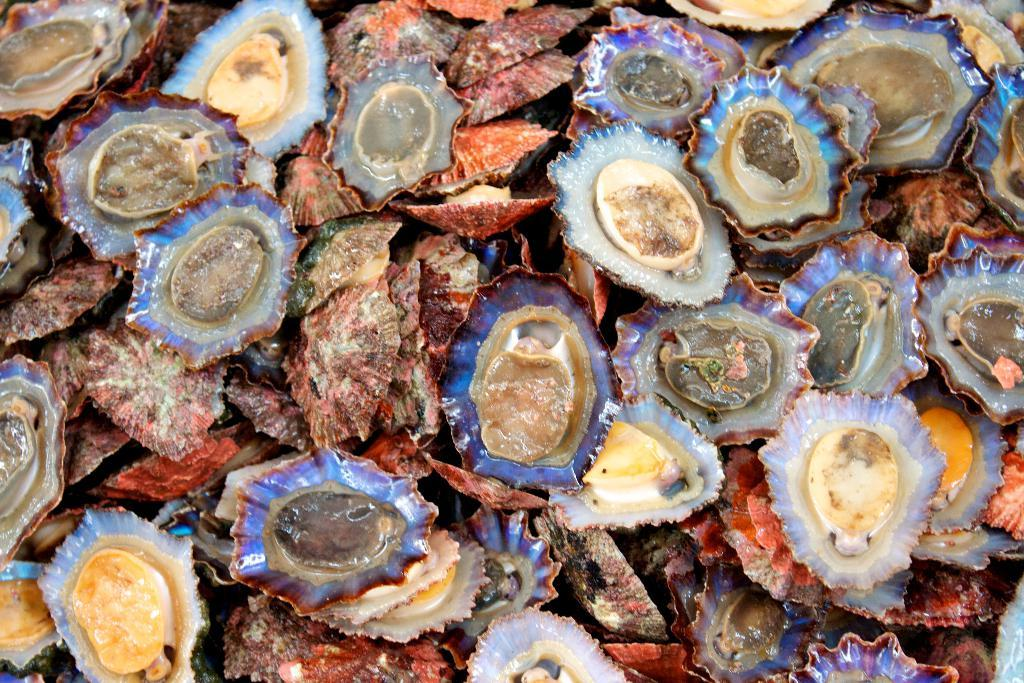What type of objects can be seen in the image? There are shells in the image. Can you describe the shells in more detail? Some shells are open, while others are closed. The open shells have a layer of multi-colored material around them. How would you describe the appearance of the multi-colored layer? The multi-colored layer is described as pretty and mesmerizing. What type of ghost is depicted wearing the apparel in the image? There is no ghost or apparel present in the image; it features shells with a multi-colored layer. Can you tell me if the coast is visible in the image? The provided facts do not mention the coast, so it cannot be determined from the image. 